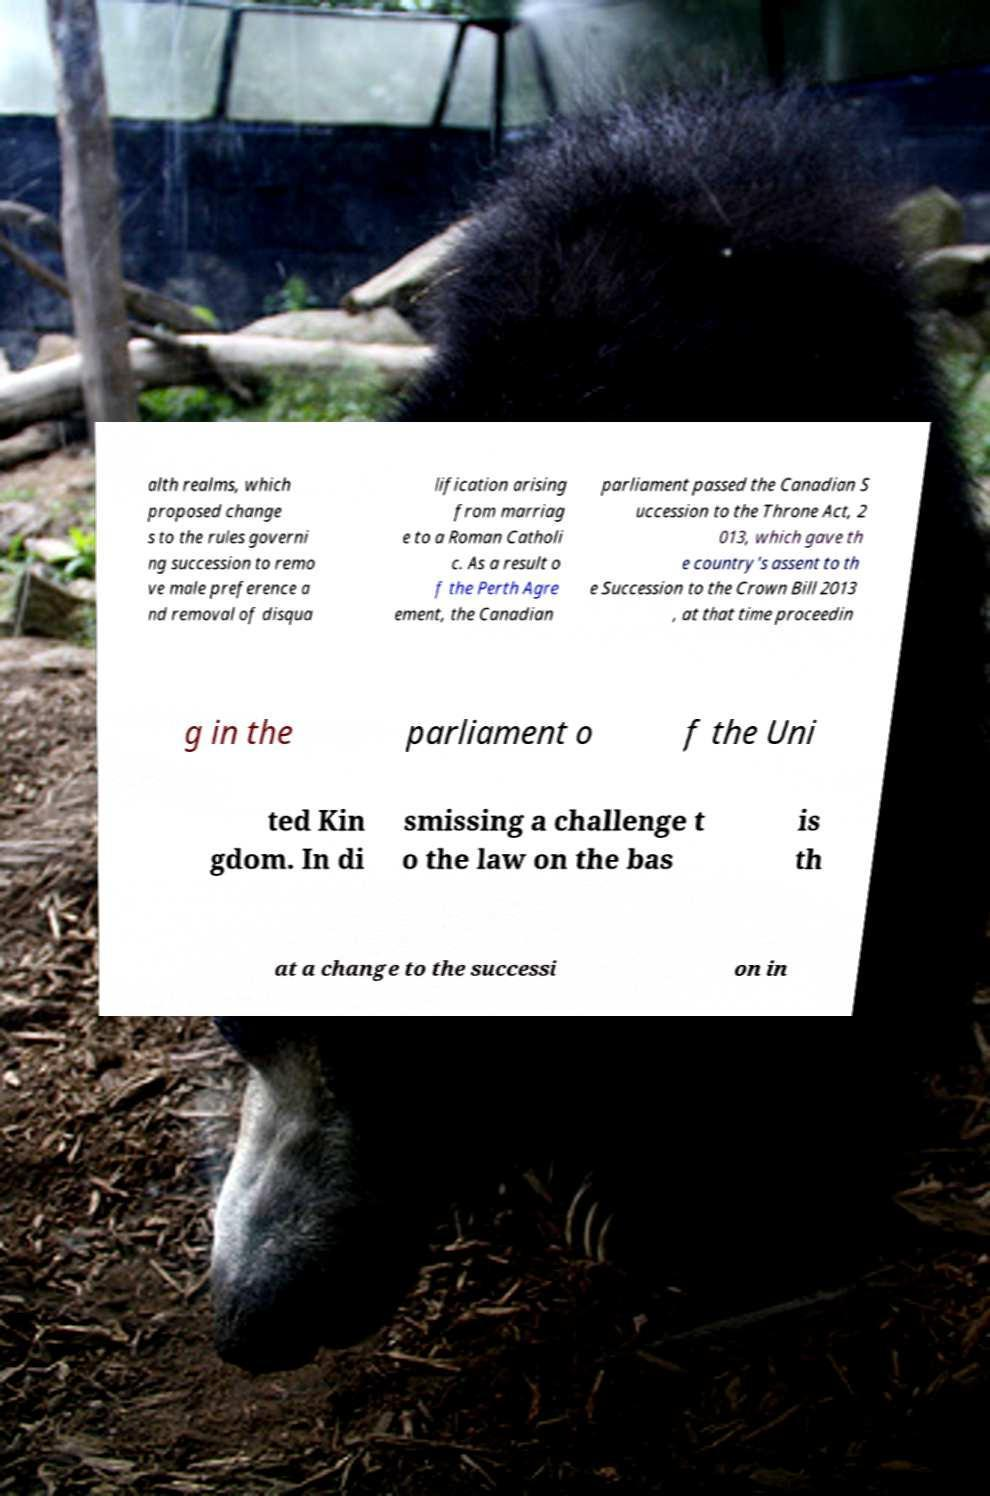What messages or text are displayed in this image? I need them in a readable, typed format. alth realms, which proposed change s to the rules governi ng succession to remo ve male preference a nd removal of disqua lification arising from marriag e to a Roman Catholi c. As a result o f the Perth Agre ement, the Canadian parliament passed the Canadian S uccession to the Throne Act, 2 013, which gave th e country's assent to th e Succession to the Crown Bill 2013 , at that time proceedin g in the parliament o f the Uni ted Kin gdom. In di smissing a challenge t o the law on the bas is th at a change to the successi on in 